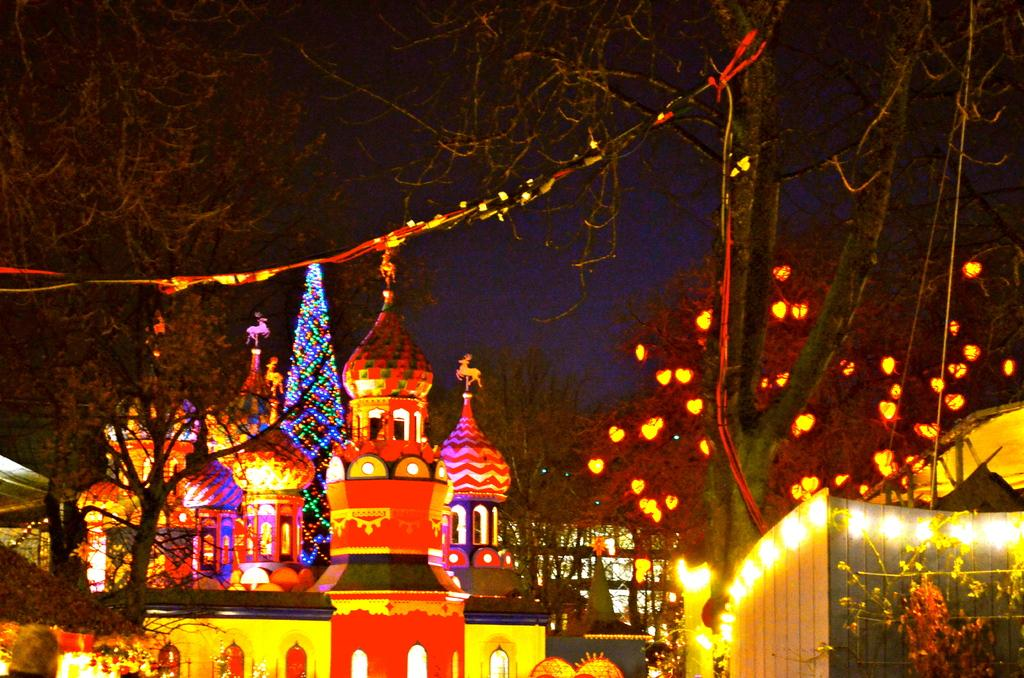What is located at the bottom of the image? There are buildings, decorations, lights, trees, and plants at the bottom of the image. What is the purpose of the decorations at the bottom of the image? The purpose of the decorations is not specified in the facts, but they are present at the bottom of the image. What is visible at the top of the image? Trees, lightnings, and the sky are visible at the top of the image. Can you see a worm crawling on the pan in the image? There is no pan or worm present in the image. What type of bean is growing on the trees at the top of the image? There are no beans growing on the trees in the image; only trees and lightnings are visible at the top. 